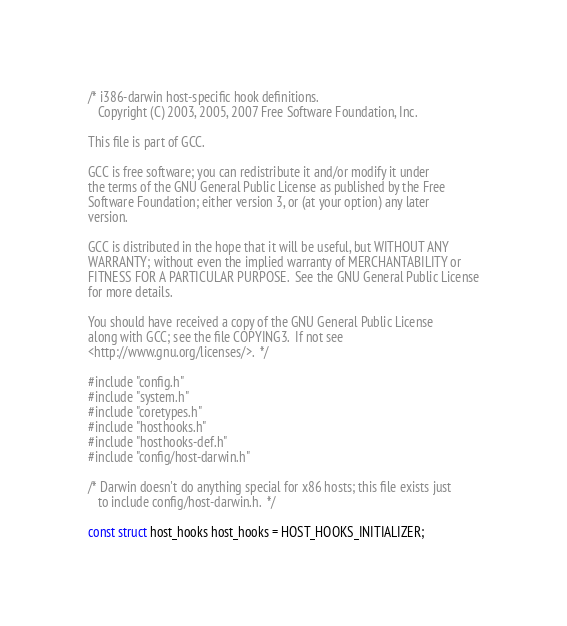<code> <loc_0><loc_0><loc_500><loc_500><_C_>/* i386-darwin host-specific hook definitions.
   Copyright (C) 2003, 2005, 2007 Free Software Foundation, Inc.

This file is part of GCC.

GCC is free software; you can redistribute it and/or modify it under
the terms of the GNU General Public License as published by the Free
Software Foundation; either version 3, or (at your option) any later
version.

GCC is distributed in the hope that it will be useful, but WITHOUT ANY
WARRANTY; without even the implied warranty of MERCHANTABILITY or
FITNESS FOR A PARTICULAR PURPOSE.  See the GNU General Public License
for more details.

You should have received a copy of the GNU General Public License
along with GCC; see the file COPYING3.  If not see
<http://www.gnu.org/licenses/>.  */

#include "config.h"
#include "system.h"
#include "coretypes.h"
#include "hosthooks.h"
#include "hosthooks-def.h"
#include "config/host-darwin.h"

/* Darwin doesn't do anything special for x86 hosts; this file exists just
   to include config/host-darwin.h.  */

const struct host_hooks host_hooks = HOST_HOOKS_INITIALIZER;
</code> 